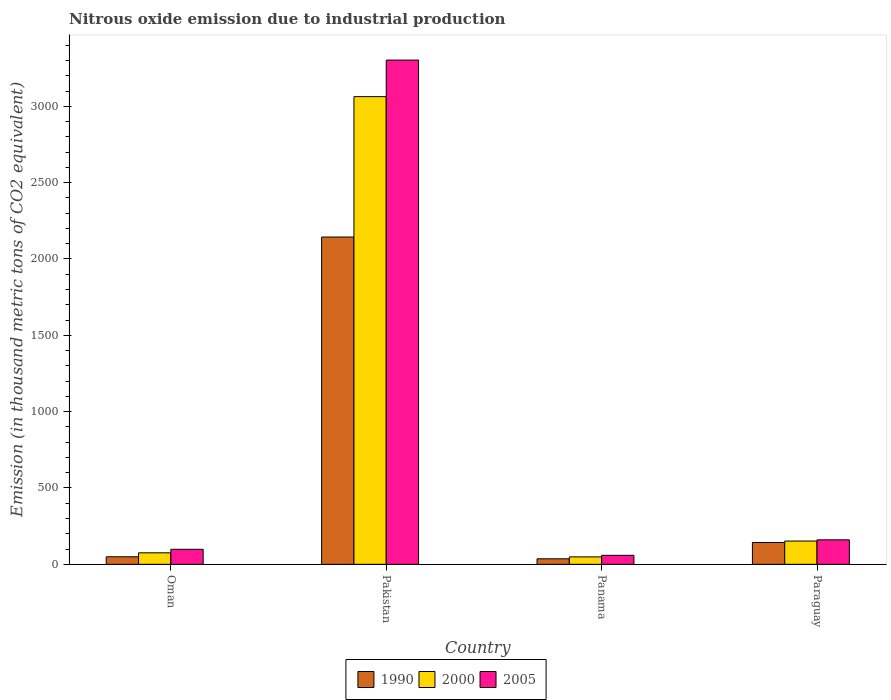How many different coloured bars are there?
Ensure brevity in your answer.  3. How many groups of bars are there?
Give a very brief answer. 4. Are the number of bars per tick equal to the number of legend labels?
Offer a terse response. Yes. Are the number of bars on each tick of the X-axis equal?
Provide a short and direct response. Yes. How many bars are there on the 2nd tick from the right?
Your answer should be very brief. 3. What is the label of the 4th group of bars from the left?
Keep it short and to the point. Paraguay. In how many cases, is the number of bars for a given country not equal to the number of legend labels?
Make the answer very short. 0. What is the amount of nitrous oxide emitted in 1990 in Paraguay?
Your response must be concise. 143. Across all countries, what is the maximum amount of nitrous oxide emitted in 1990?
Offer a very short reply. 2143.8. Across all countries, what is the minimum amount of nitrous oxide emitted in 2000?
Make the answer very short. 48.8. In which country was the amount of nitrous oxide emitted in 2005 minimum?
Make the answer very short. Panama. What is the total amount of nitrous oxide emitted in 1990 in the graph?
Offer a very short reply. 2372.4. What is the difference between the amount of nitrous oxide emitted in 2000 in Oman and that in Paraguay?
Provide a succinct answer. -77.1. What is the difference between the amount of nitrous oxide emitted in 2000 in Oman and the amount of nitrous oxide emitted in 2005 in Panama?
Provide a succinct answer. 16.4. What is the average amount of nitrous oxide emitted in 2005 per country?
Your answer should be very brief. 905.23. What is the difference between the amount of nitrous oxide emitted of/in 1990 and amount of nitrous oxide emitted of/in 2000 in Panama?
Keep it short and to the point. -12.6. What is the ratio of the amount of nitrous oxide emitted in 2000 in Oman to that in Panama?
Keep it short and to the point. 1.55. Is the amount of nitrous oxide emitted in 1990 in Pakistan less than that in Paraguay?
Your answer should be compact. No. Is the difference between the amount of nitrous oxide emitted in 1990 in Oman and Pakistan greater than the difference between the amount of nitrous oxide emitted in 2000 in Oman and Pakistan?
Offer a terse response. Yes. What is the difference between the highest and the second highest amount of nitrous oxide emitted in 2000?
Offer a very short reply. 77.1. What is the difference between the highest and the lowest amount of nitrous oxide emitted in 2005?
Offer a very short reply. 3243.9. In how many countries, is the amount of nitrous oxide emitted in 2005 greater than the average amount of nitrous oxide emitted in 2005 taken over all countries?
Offer a terse response. 1. What does the 3rd bar from the right in Pakistan represents?
Ensure brevity in your answer.  1990. Is it the case that in every country, the sum of the amount of nitrous oxide emitted in 1990 and amount of nitrous oxide emitted in 2000 is greater than the amount of nitrous oxide emitted in 2005?
Make the answer very short. Yes. Are all the bars in the graph horizontal?
Give a very brief answer. No. How many countries are there in the graph?
Offer a very short reply. 4. Are the values on the major ticks of Y-axis written in scientific E-notation?
Offer a terse response. No. Does the graph contain any zero values?
Your response must be concise. No. Where does the legend appear in the graph?
Keep it short and to the point. Bottom center. How many legend labels are there?
Give a very brief answer. 3. How are the legend labels stacked?
Give a very brief answer. Horizontal. What is the title of the graph?
Your response must be concise. Nitrous oxide emission due to industrial production. What is the label or title of the X-axis?
Your answer should be compact. Country. What is the label or title of the Y-axis?
Your response must be concise. Emission (in thousand metric tons of CO2 equivalent). What is the Emission (in thousand metric tons of CO2 equivalent) of 1990 in Oman?
Your answer should be very brief. 49.4. What is the Emission (in thousand metric tons of CO2 equivalent) in 2000 in Oman?
Your answer should be compact. 75.4. What is the Emission (in thousand metric tons of CO2 equivalent) in 2005 in Oman?
Your answer should be compact. 98.4. What is the Emission (in thousand metric tons of CO2 equivalent) of 1990 in Pakistan?
Keep it short and to the point. 2143.8. What is the Emission (in thousand metric tons of CO2 equivalent) in 2000 in Pakistan?
Keep it short and to the point. 3063.5. What is the Emission (in thousand metric tons of CO2 equivalent) in 2005 in Pakistan?
Provide a short and direct response. 3302.9. What is the Emission (in thousand metric tons of CO2 equivalent) in 1990 in Panama?
Provide a short and direct response. 36.2. What is the Emission (in thousand metric tons of CO2 equivalent) in 2000 in Panama?
Your response must be concise. 48.8. What is the Emission (in thousand metric tons of CO2 equivalent) in 2005 in Panama?
Your response must be concise. 59. What is the Emission (in thousand metric tons of CO2 equivalent) in 1990 in Paraguay?
Keep it short and to the point. 143. What is the Emission (in thousand metric tons of CO2 equivalent) of 2000 in Paraguay?
Keep it short and to the point. 152.5. What is the Emission (in thousand metric tons of CO2 equivalent) of 2005 in Paraguay?
Your answer should be compact. 160.6. Across all countries, what is the maximum Emission (in thousand metric tons of CO2 equivalent) of 1990?
Ensure brevity in your answer.  2143.8. Across all countries, what is the maximum Emission (in thousand metric tons of CO2 equivalent) of 2000?
Make the answer very short. 3063.5. Across all countries, what is the maximum Emission (in thousand metric tons of CO2 equivalent) in 2005?
Your answer should be compact. 3302.9. Across all countries, what is the minimum Emission (in thousand metric tons of CO2 equivalent) of 1990?
Offer a terse response. 36.2. Across all countries, what is the minimum Emission (in thousand metric tons of CO2 equivalent) in 2000?
Make the answer very short. 48.8. Across all countries, what is the minimum Emission (in thousand metric tons of CO2 equivalent) of 2005?
Give a very brief answer. 59. What is the total Emission (in thousand metric tons of CO2 equivalent) in 1990 in the graph?
Provide a succinct answer. 2372.4. What is the total Emission (in thousand metric tons of CO2 equivalent) in 2000 in the graph?
Offer a terse response. 3340.2. What is the total Emission (in thousand metric tons of CO2 equivalent) in 2005 in the graph?
Keep it short and to the point. 3620.9. What is the difference between the Emission (in thousand metric tons of CO2 equivalent) in 1990 in Oman and that in Pakistan?
Your answer should be very brief. -2094.4. What is the difference between the Emission (in thousand metric tons of CO2 equivalent) of 2000 in Oman and that in Pakistan?
Your response must be concise. -2988.1. What is the difference between the Emission (in thousand metric tons of CO2 equivalent) of 2005 in Oman and that in Pakistan?
Keep it short and to the point. -3204.5. What is the difference between the Emission (in thousand metric tons of CO2 equivalent) of 2000 in Oman and that in Panama?
Ensure brevity in your answer.  26.6. What is the difference between the Emission (in thousand metric tons of CO2 equivalent) in 2005 in Oman and that in Panama?
Ensure brevity in your answer.  39.4. What is the difference between the Emission (in thousand metric tons of CO2 equivalent) of 1990 in Oman and that in Paraguay?
Your response must be concise. -93.6. What is the difference between the Emission (in thousand metric tons of CO2 equivalent) of 2000 in Oman and that in Paraguay?
Provide a succinct answer. -77.1. What is the difference between the Emission (in thousand metric tons of CO2 equivalent) in 2005 in Oman and that in Paraguay?
Give a very brief answer. -62.2. What is the difference between the Emission (in thousand metric tons of CO2 equivalent) of 1990 in Pakistan and that in Panama?
Make the answer very short. 2107.6. What is the difference between the Emission (in thousand metric tons of CO2 equivalent) of 2000 in Pakistan and that in Panama?
Keep it short and to the point. 3014.7. What is the difference between the Emission (in thousand metric tons of CO2 equivalent) of 2005 in Pakistan and that in Panama?
Offer a terse response. 3243.9. What is the difference between the Emission (in thousand metric tons of CO2 equivalent) of 1990 in Pakistan and that in Paraguay?
Keep it short and to the point. 2000.8. What is the difference between the Emission (in thousand metric tons of CO2 equivalent) of 2000 in Pakistan and that in Paraguay?
Your answer should be very brief. 2911. What is the difference between the Emission (in thousand metric tons of CO2 equivalent) of 2005 in Pakistan and that in Paraguay?
Ensure brevity in your answer.  3142.3. What is the difference between the Emission (in thousand metric tons of CO2 equivalent) in 1990 in Panama and that in Paraguay?
Your response must be concise. -106.8. What is the difference between the Emission (in thousand metric tons of CO2 equivalent) in 2000 in Panama and that in Paraguay?
Keep it short and to the point. -103.7. What is the difference between the Emission (in thousand metric tons of CO2 equivalent) of 2005 in Panama and that in Paraguay?
Keep it short and to the point. -101.6. What is the difference between the Emission (in thousand metric tons of CO2 equivalent) in 1990 in Oman and the Emission (in thousand metric tons of CO2 equivalent) in 2000 in Pakistan?
Provide a succinct answer. -3014.1. What is the difference between the Emission (in thousand metric tons of CO2 equivalent) of 1990 in Oman and the Emission (in thousand metric tons of CO2 equivalent) of 2005 in Pakistan?
Ensure brevity in your answer.  -3253.5. What is the difference between the Emission (in thousand metric tons of CO2 equivalent) of 2000 in Oman and the Emission (in thousand metric tons of CO2 equivalent) of 2005 in Pakistan?
Offer a terse response. -3227.5. What is the difference between the Emission (in thousand metric tons of CO2 equivalent) in 1990 in Oman and the Emission (in thousand metric tons of CO2 equivalent) in 2005 in Panama?
Keep it short and to the point. -9.6. What is the difference between the Emission (in thousand metric tons of CO2 equivalent) of 2000 in Oman and the Emission (in thousand metric tons of CO2 equivalent) of 2005 in Panama?
Offer a very short reply. 16.4. What is the difference between the Emission (in thousand metric tons of CO2 equivalent) in 1990 in Oman and the Emission (in thousand metric tons of CO2 equivalent) in 2000 in Paraguay?
Your answer should be compact. -103.1. What is the difference between the Emission (in thousand metric tons of CO2 equivalent) of 1990 in Oman and the Emission (in thousand metric tons of CO2 equivalent) of 2005 in Paraguay?
Keep it short and to the point. -111.2. What is the difference between the Emission (in thousand metric tons of CO2 equivalent) of 2000 in Oman and the Emission (in thousand metric tons of CO2 equivalent) of 2005 in Paraguay?
Make the answer very short. -85.2. What is the difference between the Emission (in thousand metric tons of CO2 equivalent) in 1990 in Pakistan and the Emission (in thousand metric tons of CO2 equivalent) in 2000 in Panama?
Your answer should be compact. 2095. What is the difference between the Emission (in thousand metric tons of CO2 equivalent) in 1990 in Pakistan and the Emission (in thousand metric tons of CO2 equivalent) in 2005 in Panama?
Your answer should be very brief. 2084.8. What is the difference between the Emission (in thousand metric tons of CO2 equivalent) of 2000 in Pakistan and the Emission (in thousand metric tons of CO2 equivalent) of 2005 in Panama?
Ensure brevity in your answer.  3004.5. What is the difference between the Emission (in thousand metric tons of CO2 equivalent) of 1990 in Pakistan and the Emission (in thousand metric tons of CO2 equivalent) of 2000 in Paraguay?
Offer a very short reply. 1991.3. What is the difference between the Emission (in thousand metric tons of CO2 equivalent) of 1990 in Pakistan and the Emission (in thousand metric tons of CO2 equivalent) of 2005 in Paraguay?
Offer a very short reply. 1983.2. What is the difference between the Emission (in thousand metric tons of CO2 equivalent) in 2000 in Pakistan and the Emission (in thousand metric tons of CO2 equivalent) in 2005 in Paraguay?
Offer a very short reply. 2902.9. What is the difference between the Emission (in thousand metric tons of CO2 equivalent) of 1990 in Panama and the Emission (in thousand metric tons of CO2 equivalent) of 2000 in Paraguay?
Offer a terse response. -116.3. What is the difference between the Emission (in thousand metric tons of CO2 equivalent) in 1990 in Panama and the Emission (in thousand metric tons of CO2 equivalent) in 2005 in Paraguay?
Provide a succinct answer. -124.4. What is the difference between the Emission (in thousand metric tons of CO2 equivalent) in 2000 in Panama and the Emission (in thousand metric tons of CO2 equivalent) in 2005 in Paraguay?
Make the answer very short. -111.8. What is the average Emission (in thousand metric tons of CO2 equivalent) of 1990 per country?
Make the answer very short. 593.1. What is the average Emission (in thousand metric tons of CO2 equivalent) in 2000 per country?
Make the answer very short. 835.05. What is the average Emission (in thousand metric tons of CO2 equivalent) in 2005 per country?
Ensure brevity in your answer.  905.23. What is the difference between the Emission (in thousand metric tons of CO2 equivalent) of 1990 and Emission (in thousand metric tons of CO2 equivalent) of 2005 in Oman?
Provide a succinct answer. -49. What is the difference between the Emission (in thousand metric tons of CO2 equivalent) in 1990 and Emission (in thousand metric tons of CO2 equivalent) in 2000 in Pakistan?
Your answer should be very brief. -919.7. What is the difference between the Emission (in thousand metric tons of CO2 equivalent) of 1990 and Emission (in thousand metric tons of CO2 equivalent) of 2005 in Pakistan?
Provide a short and direct response. -1159.1. What is the difference between the Emission (in thousand metric tons of CO2 equivalent) of 2000 and Emission (in thousand metric tons of CO2 equivalent) of 2005 in Pakistan?
Offer a very short reply. -239.4. What is the difference between the Emission (in thousand metric tons of CO2 equivalent) of 1990 and Emission (in thousand metric tons of CO2 equivalent) of 2000 in Panama?
Offer a very short reply. -12.6. What is the difference between the Emission (in thousand metric tons of CO2 equivalent) in 1990 and Emission (in thousand metric tons of CO2 equivalent) in 2005 in Panama?
Ensure brevity in your answer.  -22.8. What is the difference between the Emission (in thousand metric tons of CO2 equivalent) of 2000 and Emission (in thousand metric tons of CO2 equivalent) of 2005 in Panama?
Ensure brevity in your answer.  -10.2. What is the difference between the Emission (in thousand metric tons of CO2 equivalent) of 1990 and Emission (in thousand metric tons of CO2 equivalent) of 2000 in Paraguay?
Your response must be concise. -9.5. What is the difference between the Emission (in thousand metric tons of CO2 equivalent) in 1990 and Emission (in thousand metric tons of CO2 equivalent) in 2005 in Paraguay?
Your answer should be compact. -17.6. What is the ratio of the Emission (in thousand metric tons of CO2 equivalent) in 1990 in Oman to that in Pakistan?
Offer a very short reply. 0.02. What is the ratio of the Emission (in thousand metric tons of CO2 equivalent) in 2000 in Oman to that in Pakistan?
Offer a terse response. 0.02. What is the ratio of the Emission (in thousand metric tons of CO2 equivalent) in 2005 in Oman to that in Pakistan?
Keep it short and to the point. 0.03. What is the ratio of the Emission (in thousand metric tons of CO2 equivalent) of 1990 in Oman to that in Panama?
Offer a terse response. 1.36. What is the ratio of the Emission (in thousand metric tons of CO2 equivalent) in 2000 in Oman to that in Panama?
Keep it short and to the point. 1.55. What is the ratio of the Emission (in thousand metric tons of CO2 equivalent) in 2005 in Oman to that in Panama?
Make the answer very short. 1.67. What is the ratio of the Emission (in thousand metric tons of CO2 equivalent) in 1990 in Oman to that in Paraguay?
Your answer should be compact. 0.35. What is the ratio of the Emission (in thousand metric tons of CO2 equivalent) of 2000 in Oman to that in Paraguay?
Give a very brief answer. 0.49. What is the ratio of the Emission (in thousand metric tons of CO2 equivalent) of 2005 in Oman to that in Paraguay?
Ensure brevity in your answer.  0.61. What is the ratio of the Emission (in thousand metric tons of CO2 equivalent) of 1990 in Pakistan to that in Panama?
Provide a succinct answer. 59.22. What is the ratio of the Emission (in thousand metric tons of CO2 equivalent) in 2000 in Pakistan to that in Panama?
Provide a succinct answer. 62.78. What is the ratio of the Emission (in thousand metric tons of CO2 equivalent) in 2005 in Pakistan to that in Panama?
Provide a short and direct response. 55.98. What is the ratio of the Emission (in thousand metric tons of CO2 equivalent) in 1990 in Pakistan to that in Paraguay?
Provide a succinct answer. 14.99. What is the ratio of the Emission (in thousand metric tons of CO2 equivalent) in 2000 in Pakistan to that in Paraguay?
Provide a short and direct response. 20.09. What is the ratio of the Emission (in thousand metric tons of CO2 equivalent) of 2005 in Pakistan to that in Paraguay?
Ensure brevity in your answer.  20.57. What is the ratio of the Emission (in thousand metric tons of CO2 equivalent) of 1990 in Panama to that in Paraguay?
Provide a short and direct response. 0.25. What is the ratio of the Emission (in thousand metric tons of CO2 equivalent) of 2000 in Panama to that in Paraguay?
Give a very brief answer. 0.32. What is the ratio of the Emission (in thousand metric tons of CO2 equivalent) of 2005 in Panama to that in Paraguay?
Keep it short and to the point. 0.37. What is the difference between the highest and the second highest Emission (in thousand metric tons of CO2 equivalent) in 1990?
Provide a short and direct response. 2000.8. What is the difference between the highest and the second highest Emission (in thousand metric tons of CO2 equivalent) of 2000?
Give a very brief answer. 2911. What is the difference between the highest and the second highest Emission (in thousand metric tons of CO2 equivalent) of 2005?
Your answer should be compact. 3142.3. What is the difference between the highest and the lowest Emission (in thousand metric tons of CO2 equivalent) of 1990?
Ensure brevity in your answer.  2107.6. What is the difference between the highest and the lowest Emission (in thousand metric tons of CO2 equivalent) in 2000?
Provide a succinct answer. 3014.7. What is the difference between the highest and the lowest Emission (in thousand metric tons of CO2 equivalent) of 2005?
Your answer should be compact. 3243.9. 